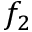<formula> <loc_0><loc_0><loc_500><loc_500>f _ { 2 }</formula> 